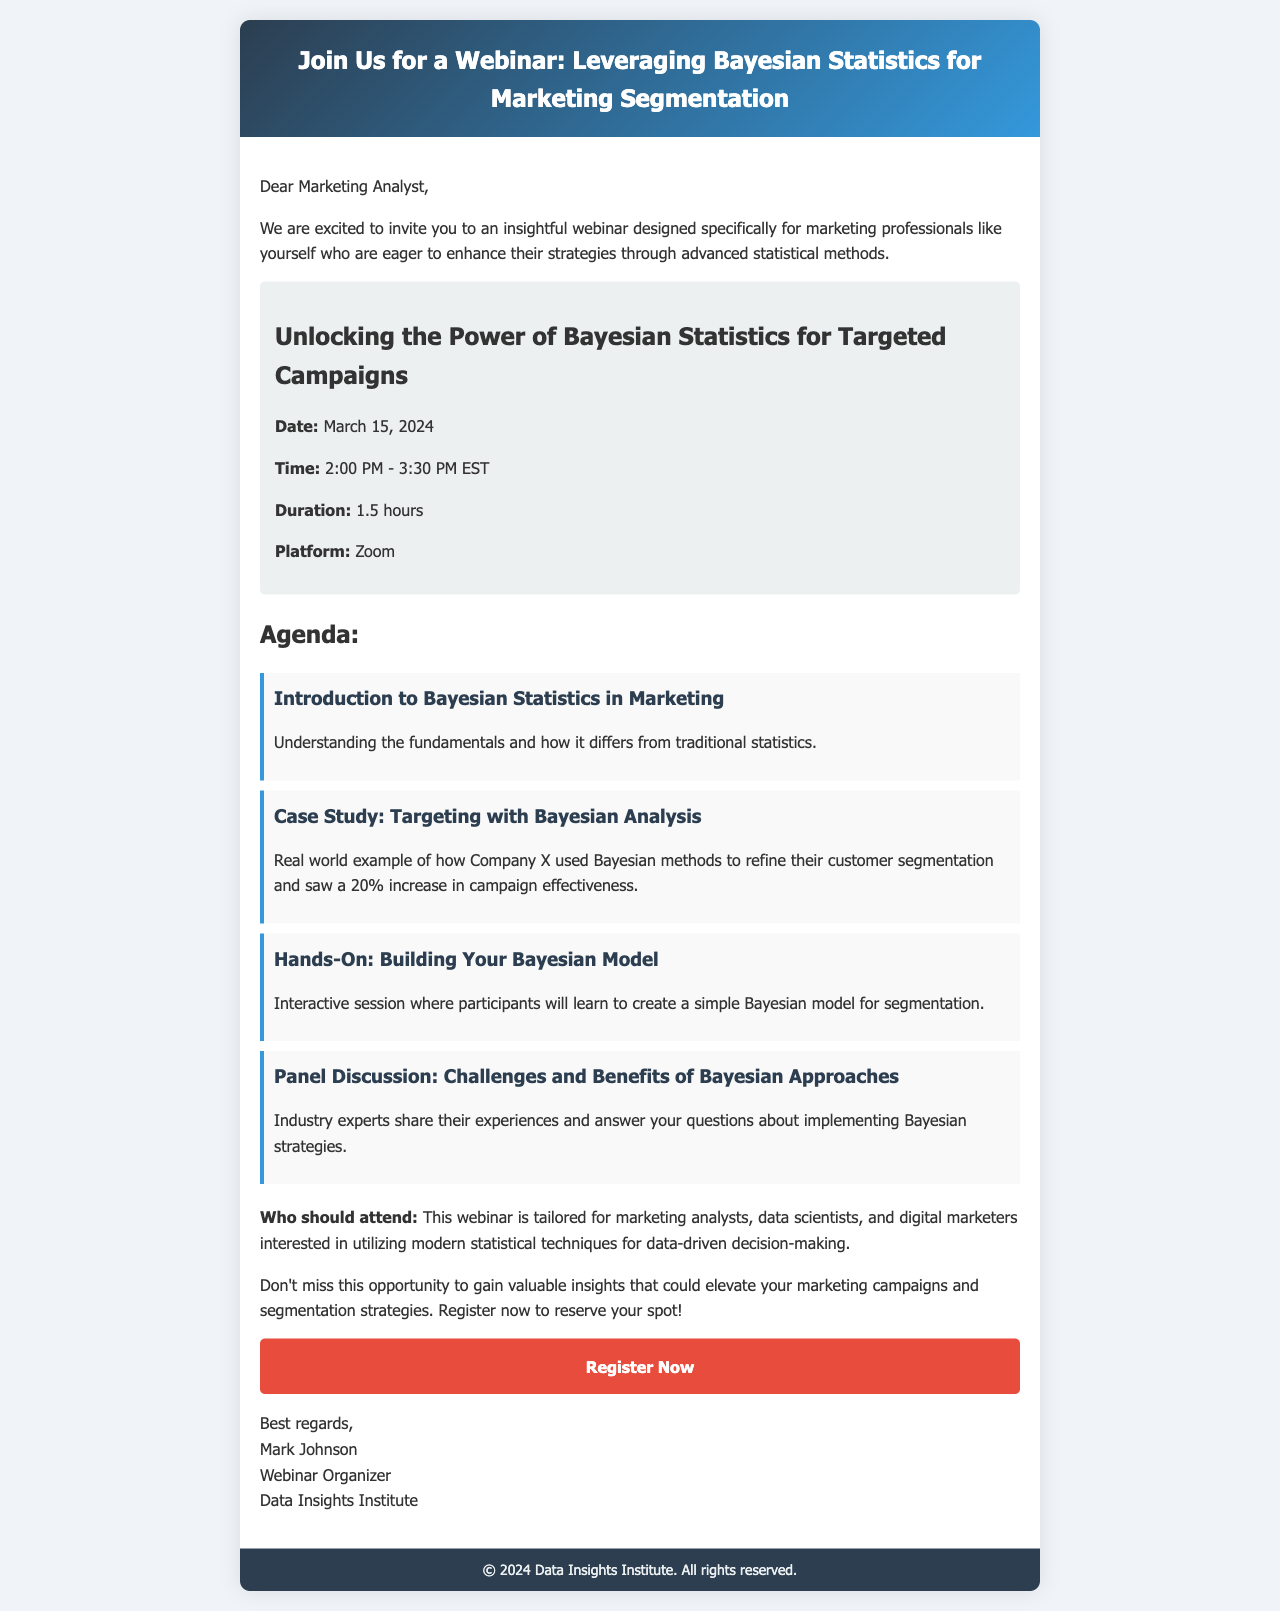What is the date of the webinar? The date of the webinar is mentioned in the event details section of the document.
Answer: March 15, 2024 What is the duration of the webinar? The duration is specified in the event details section of the document.
Answer: 1.5 hours Who is the organizer of the webinar? The organizer's name is provided at the end of the document in the signature.
Answer: Mark Johnson What is the primary focus of the webinar? The focus is detailed in the title of the webinar and the introductory paragraph.
Answer: Leveraging Bayesian Statistics for Marketing Segmentation What organizational type is the webinar tailored for? The document specifies who should attend in a dedicated section.
Answer: Marketing analysts How many agenda items are listed in the document? The number of agenda items can be counted in the agenda section of the document.
Answer: Four What platform will the webinar be held on? The platform for the webinar is mentioned in the event details section.
Answer: Zoom What is the time of the webinar? The time of the webinar is given in the event details section of the document.
Answer: 2:00 PM - 3:30 PM EST What kind of session will participants have in the webinar? The document describes the nature of one of the agenda items, indicating participant involvement.
Answer: Hands-On: Building Your Bayesian Model 